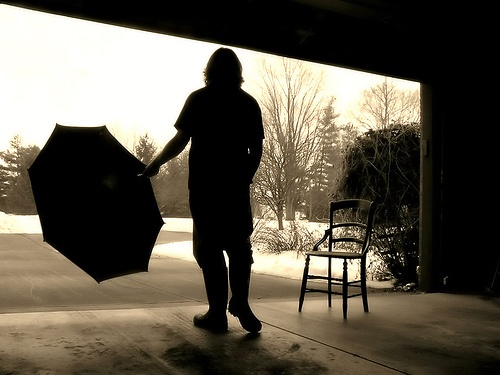Describe the objects in this image and their specific colors. I can see people in black and gray tones, umbrella in black and gray tones, and chair in black, beige, and gray tones in this image. 